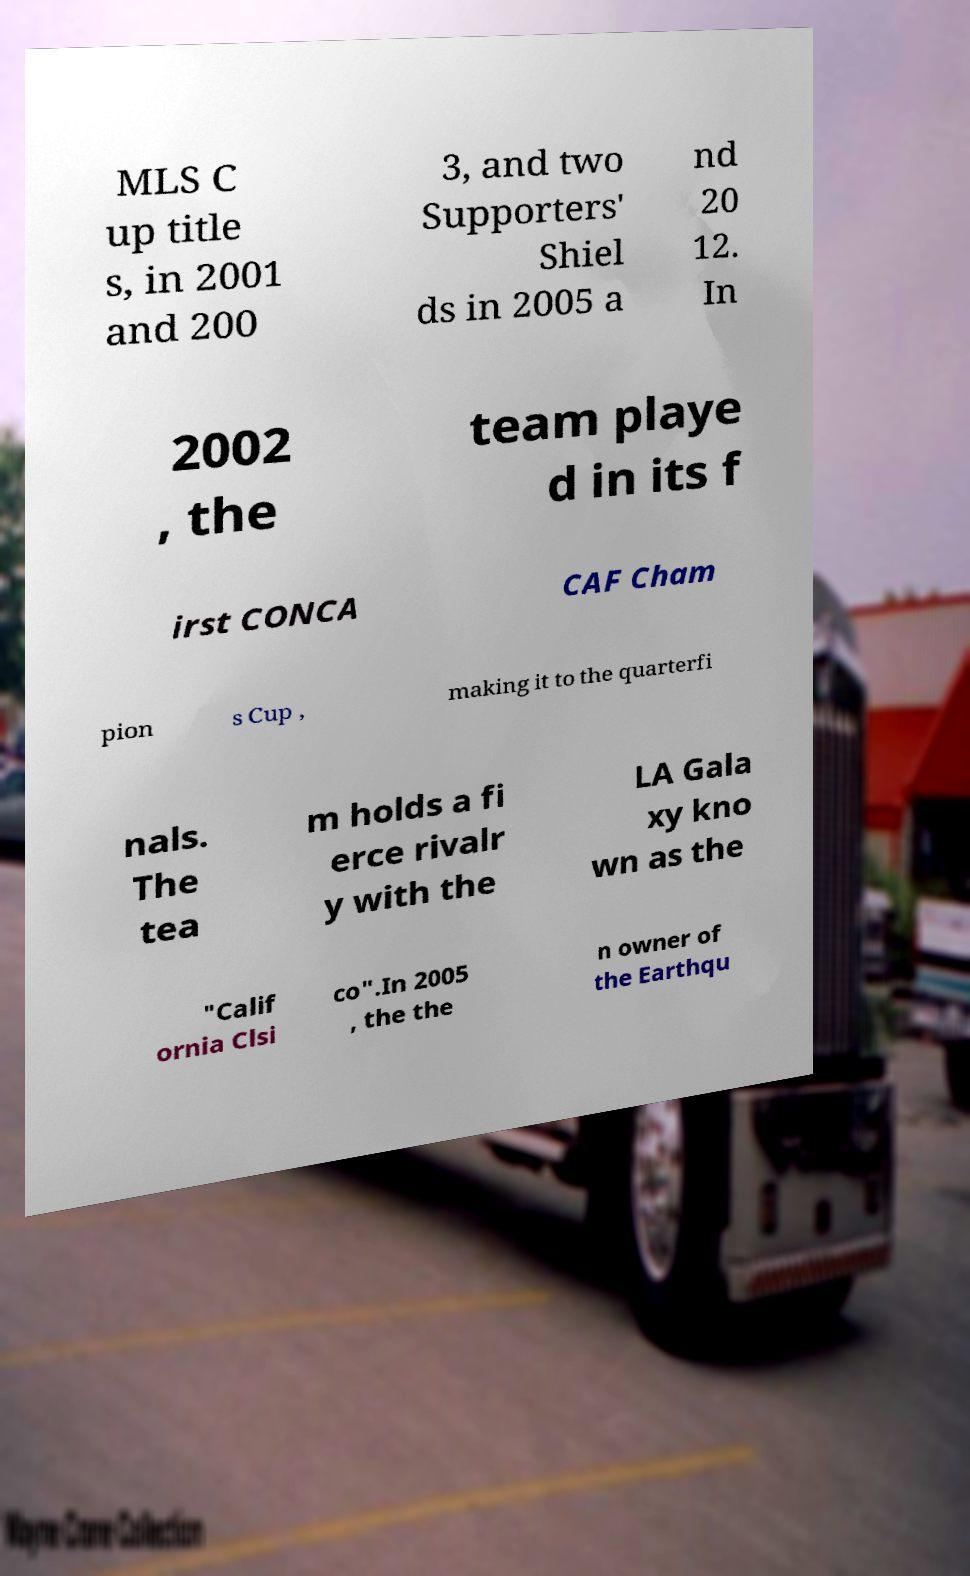What messages or text are displayed in this image? I need them in a readable, typed format. MLS C up title s, in 2001 and 200 3, and two Supporters' Shiel ds in 2005 a nd 20 12. In 2002 , the team playe d in its f irst CONCA CAF Cham pion s Cup , making it to the quarterfi nals. The tea m holds a fi erce rivalr y with the LA Gala xy kno wn as the "Calif ornia Clsi co".In 2005 , the the n owner of the Earthqu 